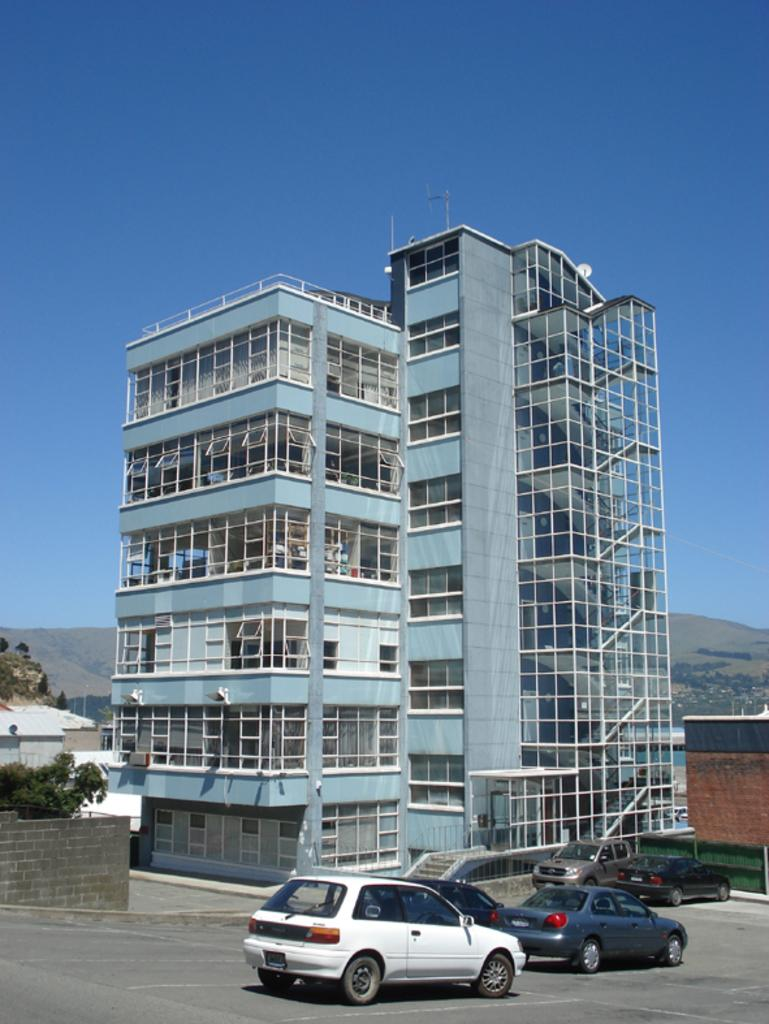What type of vehicles can be seen in the image? There are cars in the image. What is located at the bottom side of the image? There is a wall at the bottom side of the image. What can be seen in the background of the image? There are buildings, trees, mountains, and the sky visible in the background of the image. What type of pest can be seen crawling on the cars in the image? There is no pest visible on the cars in the image. What type of trade is being conducted in the image? There is no indication of any trade being conducted in the image. 